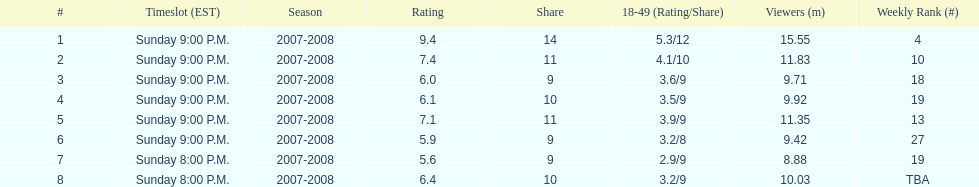Give me the full table as a dictionary. {'header': ['#', 'Timeslot (EST)', 'Season', 'Rating', 'Share', '18-49 (Rating/Share)', 'Viewers (m)', 'Weekly Rank (#)'], 'rows': [['1', 'Sunday 9:00 P.M.', '2007-2008', '9.4', '14', '5.3/12', '15.55', '4'], ['2', 'Sunday 9:00 P.M.', '2007-2008', '7.4', '11', '4.1/10', '11.83', '10'], ['3', 'Sunday 9:00 P.M.', '2007-2008', '6.0', '9', '3.6/9', '9.71', '18'], ['4', 'Sunday 9:00 P.M.', '2007-2008', '6.1', '10', '3.5/9', '9.92', '19'], ['5', 'Sunday 9:00 P.M.', '2007-2008', '7.1', '11', '3.9/9', '11.35', '13'], ['6', 'Sunday 9:00 P.M.', '2007-2008', '5.9', '9', '3.2/8', '9.42', '27'], ['7', 'Sunday 8:00 P.M.', '2007-2008', '5.6', '9', '2.9/9', '8.88', '19'], ['8', 'Sunday 8:00 P.M.', '2007-2008', '6.4', '10', '3.2/9', '10.03', 'TBA']]} Did the season wrap up at an earlier or later timeslot? Earlier. 